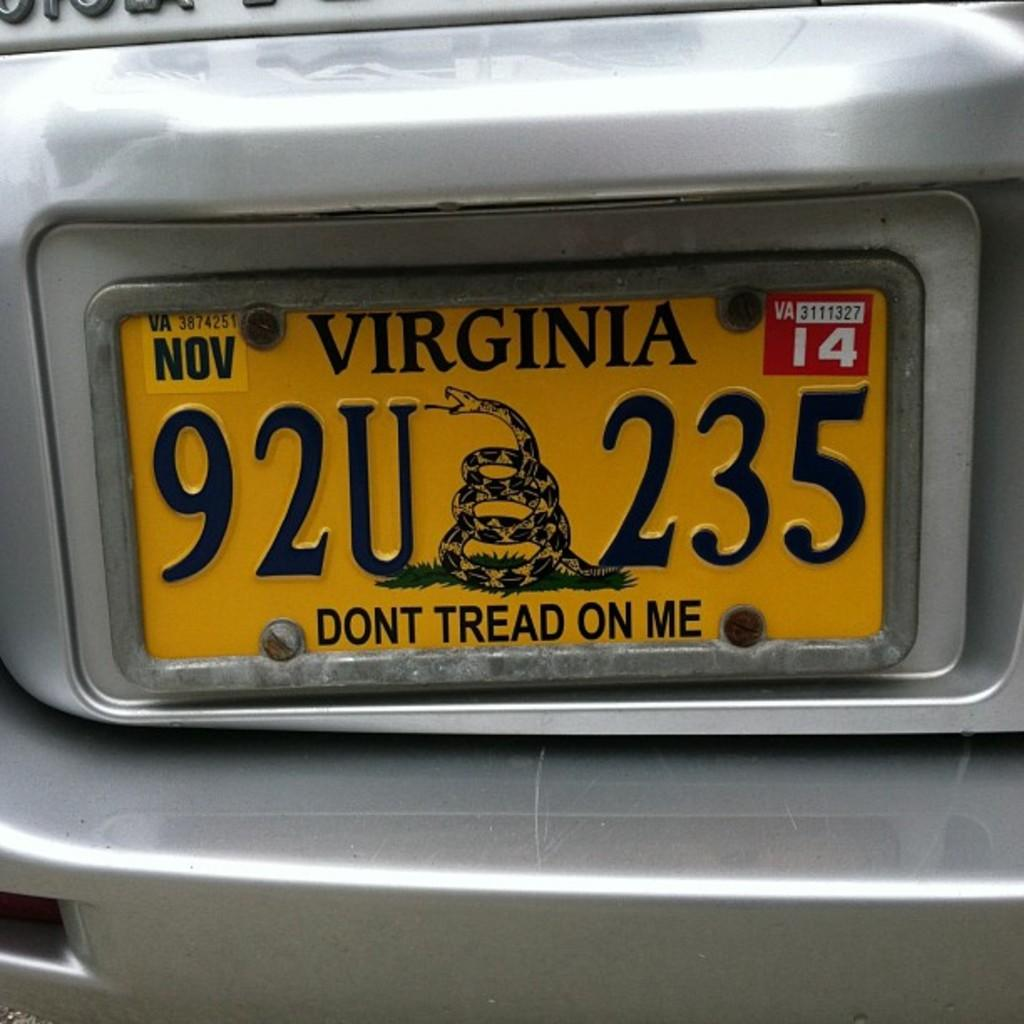Provide a one-sentence caption for the provided image. A "Don't Tread On Me" Virginia license plate. 